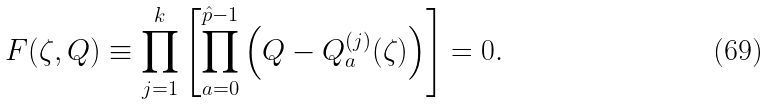Convert formula to latex. <formula><loc_0><loc_0><loc_500><loc_500>F ( \zeta , Q ) \equiv \prod _ { j = 1 } ^ { k } \left [ \prod _ { a = 0 } ^ { \hat { p } - 1 } \left ( Q - Q _ { a } ^ { ( j ) } ( \zeta ) \right ) \right ] = 0 .</formula> 